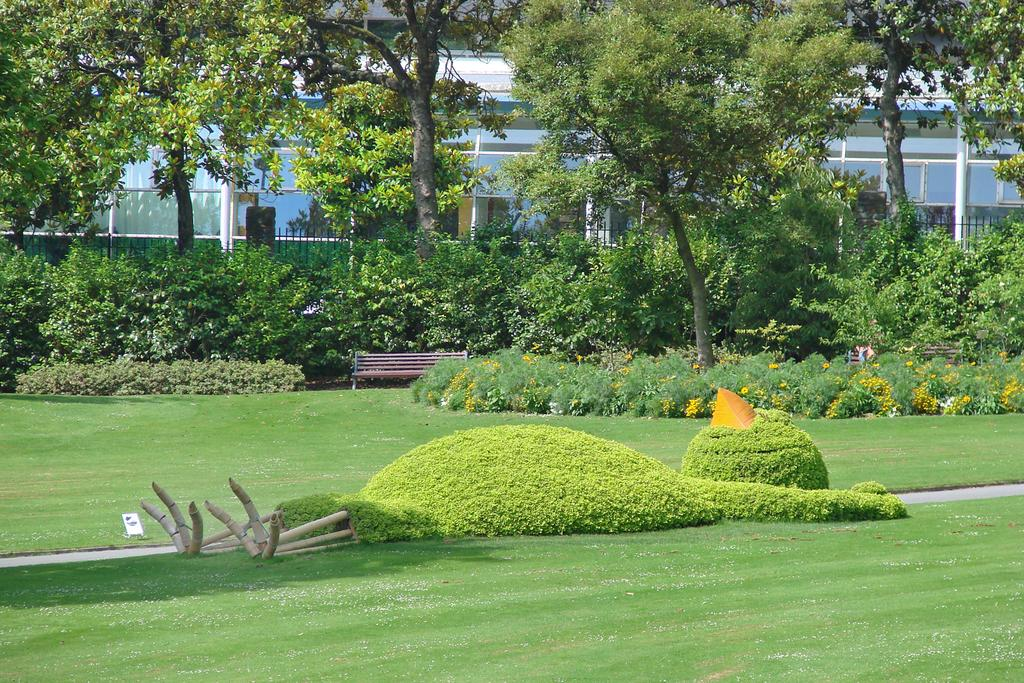What type of ground is visible at the bottom of the image? There is grass at the bottom of the image. What other natural elements can be seen in the image? There are plants in the image. What is located in the middle of the image? There is a bench in the middle of the image. What can be seen in the background of the image? There are trees, a building, and fencing in the background of the image. What type of dirt is visible on the bench in the image? There is no dirt visible on the bench in the image. What type of writing can be seen on the plants in the image? There is no writing present on the plants in the image. 